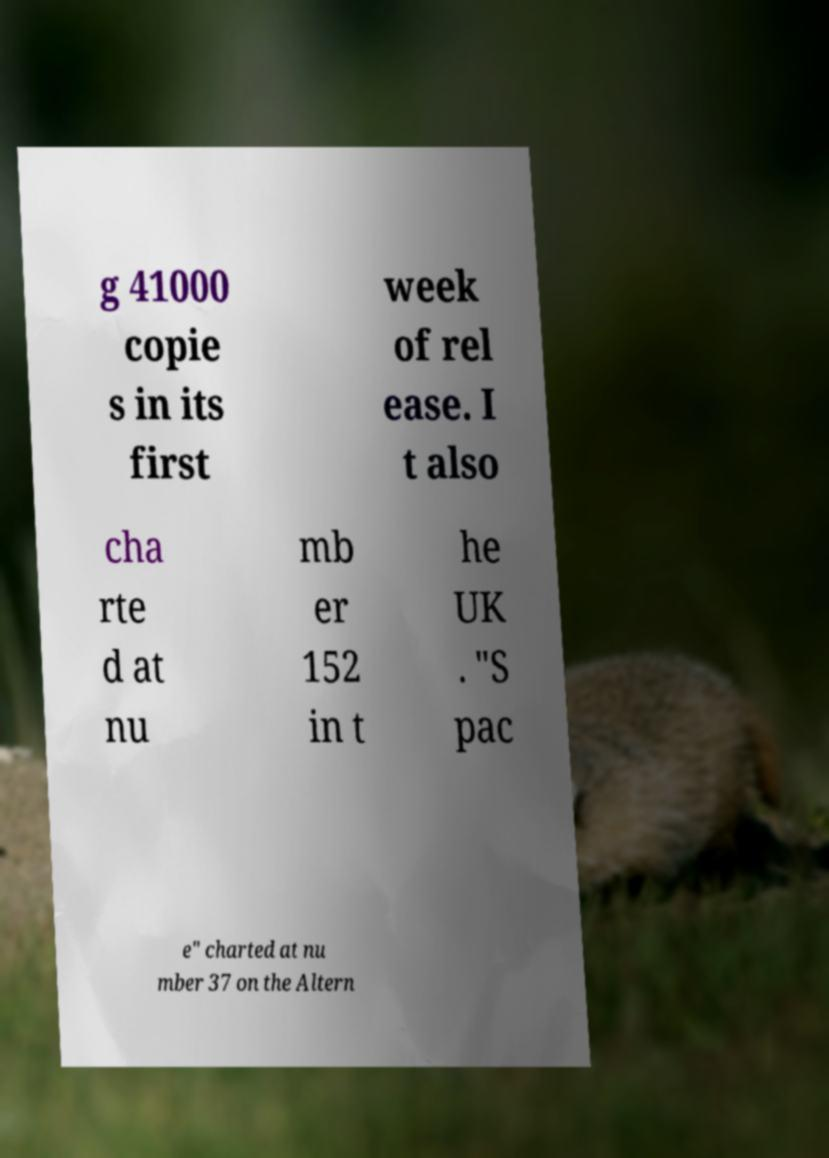Could you extract and type out the text from this image? g 41000 copie s in its first week of rel ease. I t also cha rte d at nu mb er 152 in t he UK . "S pac e" charted at nu mber 37 on the Altern 